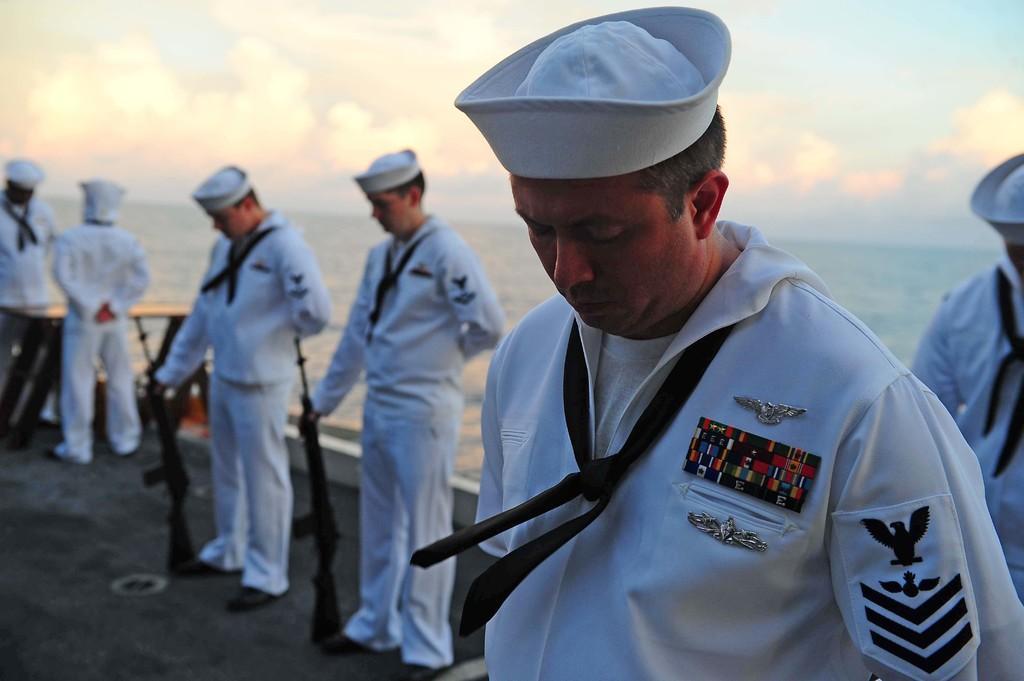Could you give a brief overview of what you see in this image? In this image I can see the group of people standing and wearing the white color dresses. These people are wearing the caps. I can see two people are holding the weapons. To the side I can see the water, clouds and the sky. 